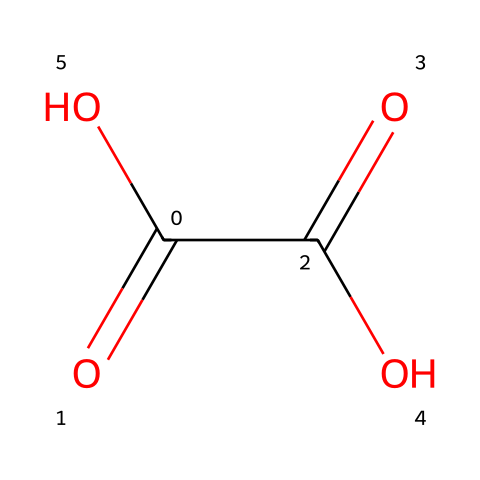How many carbon atoms are in oxalic acid? The SMILES representation shows "C(=O)(C(=O)O)O", which indicates the presence of two "C" atoms, one for each carbon in the structure.
Answer: 2 What is the functional group present in oxalic acid? Judging from the SMILES, the presence of "-C(=O)O" indicates the presence of carboxylic acid functional groups, which consist of the carbon double bonded to an oxygen and single bonded to a hydroxyl group.
Answer: carboxylic acid How many oxygen atoms are present in oxalic acid? The structure features three "O" atoms in the SMILES, coming from two carboxylic acid groups. Each group has one double-bonded and one single-bonded oxygen atom.
Answer: 4 Is oxalic acid a strong or weak acid? Understanding that oxalic acid ionizes in solution indicates it can dissociate to some degree but does not completely, pointing towards weak acid behavior rather than strong.
Answer: weak How does the structure of oxalic acid influence its cleaning properties? The two carboxylic acid groups can chelate metal ions, aiding in their removal, which explains its effectiveness in cleaning metals like brass due to its ability to bind and dissolve tarnish.
Answer: chelation What is the pH effect of oxalic acid in solutions? Since oxalic acid is a weak acid, when dissolved, it produces a solution that is not extremely acidic, implying a relatively moderate pH compared to strong acids.
Answer: moderate pH 